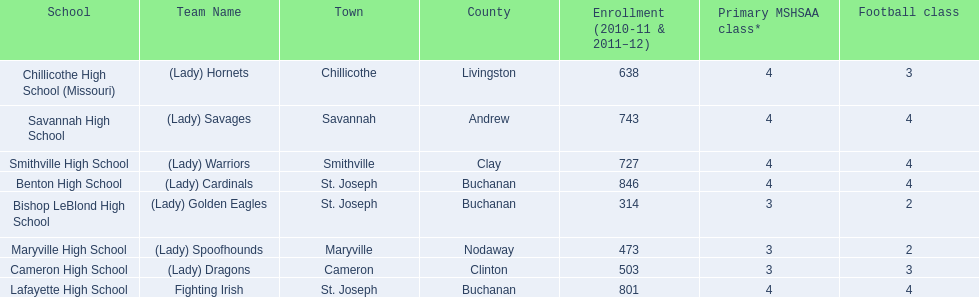What team uses green and grey as colors? Fighting Irish. What is this team called? Lafayette High School. 